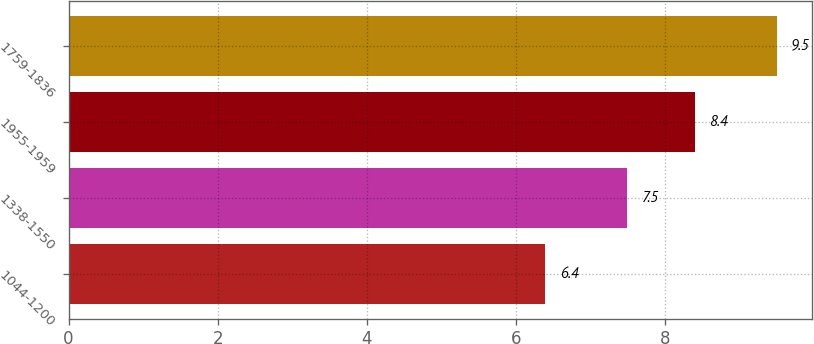Convert chart. <chart><loc_0><loc_0><loc_500><loc_500><bar_chart><fcel>1044-1200<fcel>1338-1550<fcel>1955-1959<fcel>1759-1836<nl><fcel>6.4<fcel>7.5<fcel>8.4<fcel>9.5<nl></chart> 